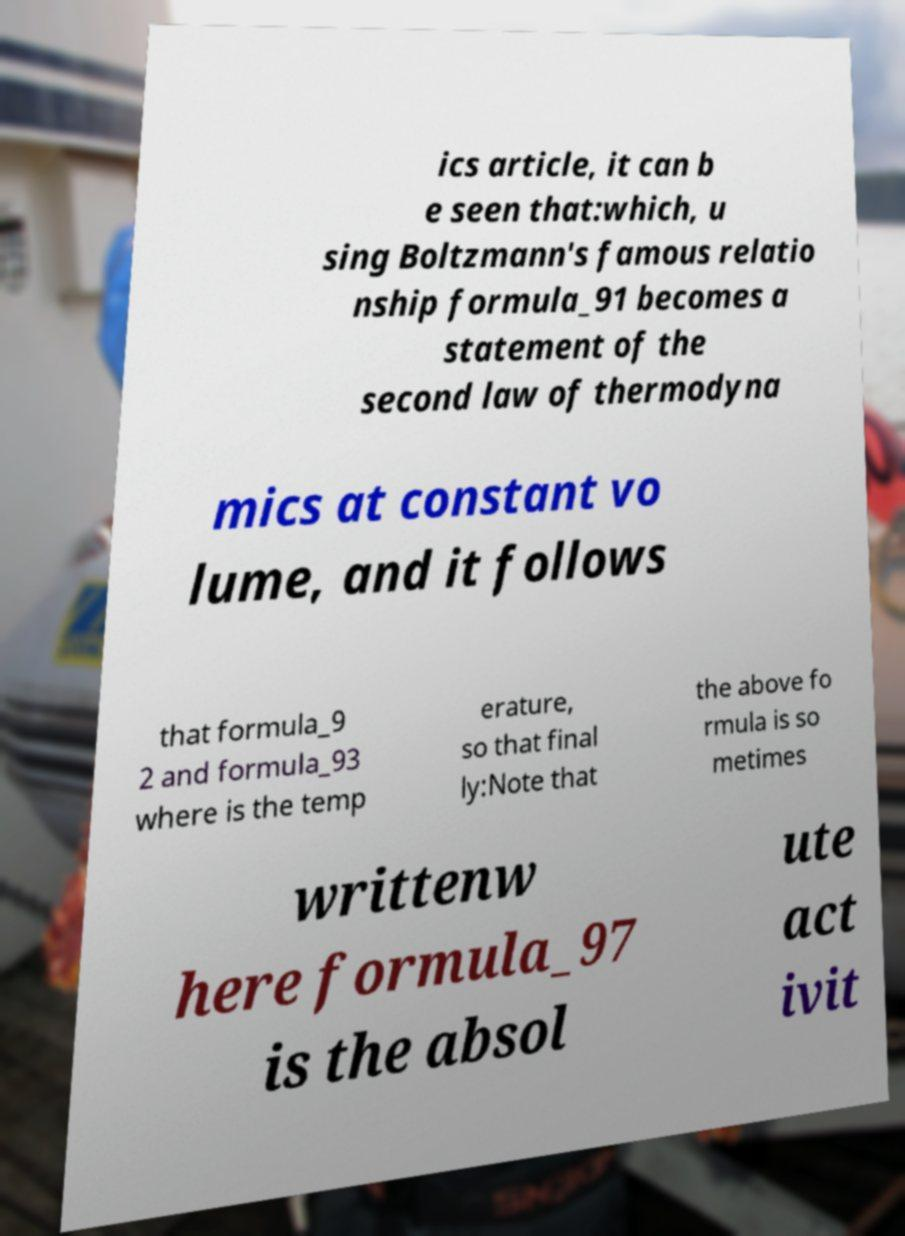What messages or text are displayed in this image? I need them in a readable, typed format. ics article, it can b e seen that:which, u sing Boltzmann's famous relatio nship formula_91 becomes a statement of the second law of thermodyna mics at constant vo lume, and it follows that formula_9 2 and formula_93 where is the temp erature, so that final ly:Note that the above fo rmula is so metimes writtenw here formula_97 is the absol ute act ivit 